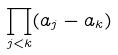Convert formula to latex. <formula><loc_0><loc_0><loc_500><loc_500>\prod _ { j < k } ( a _ { j } - a _ { k } )</formula> 